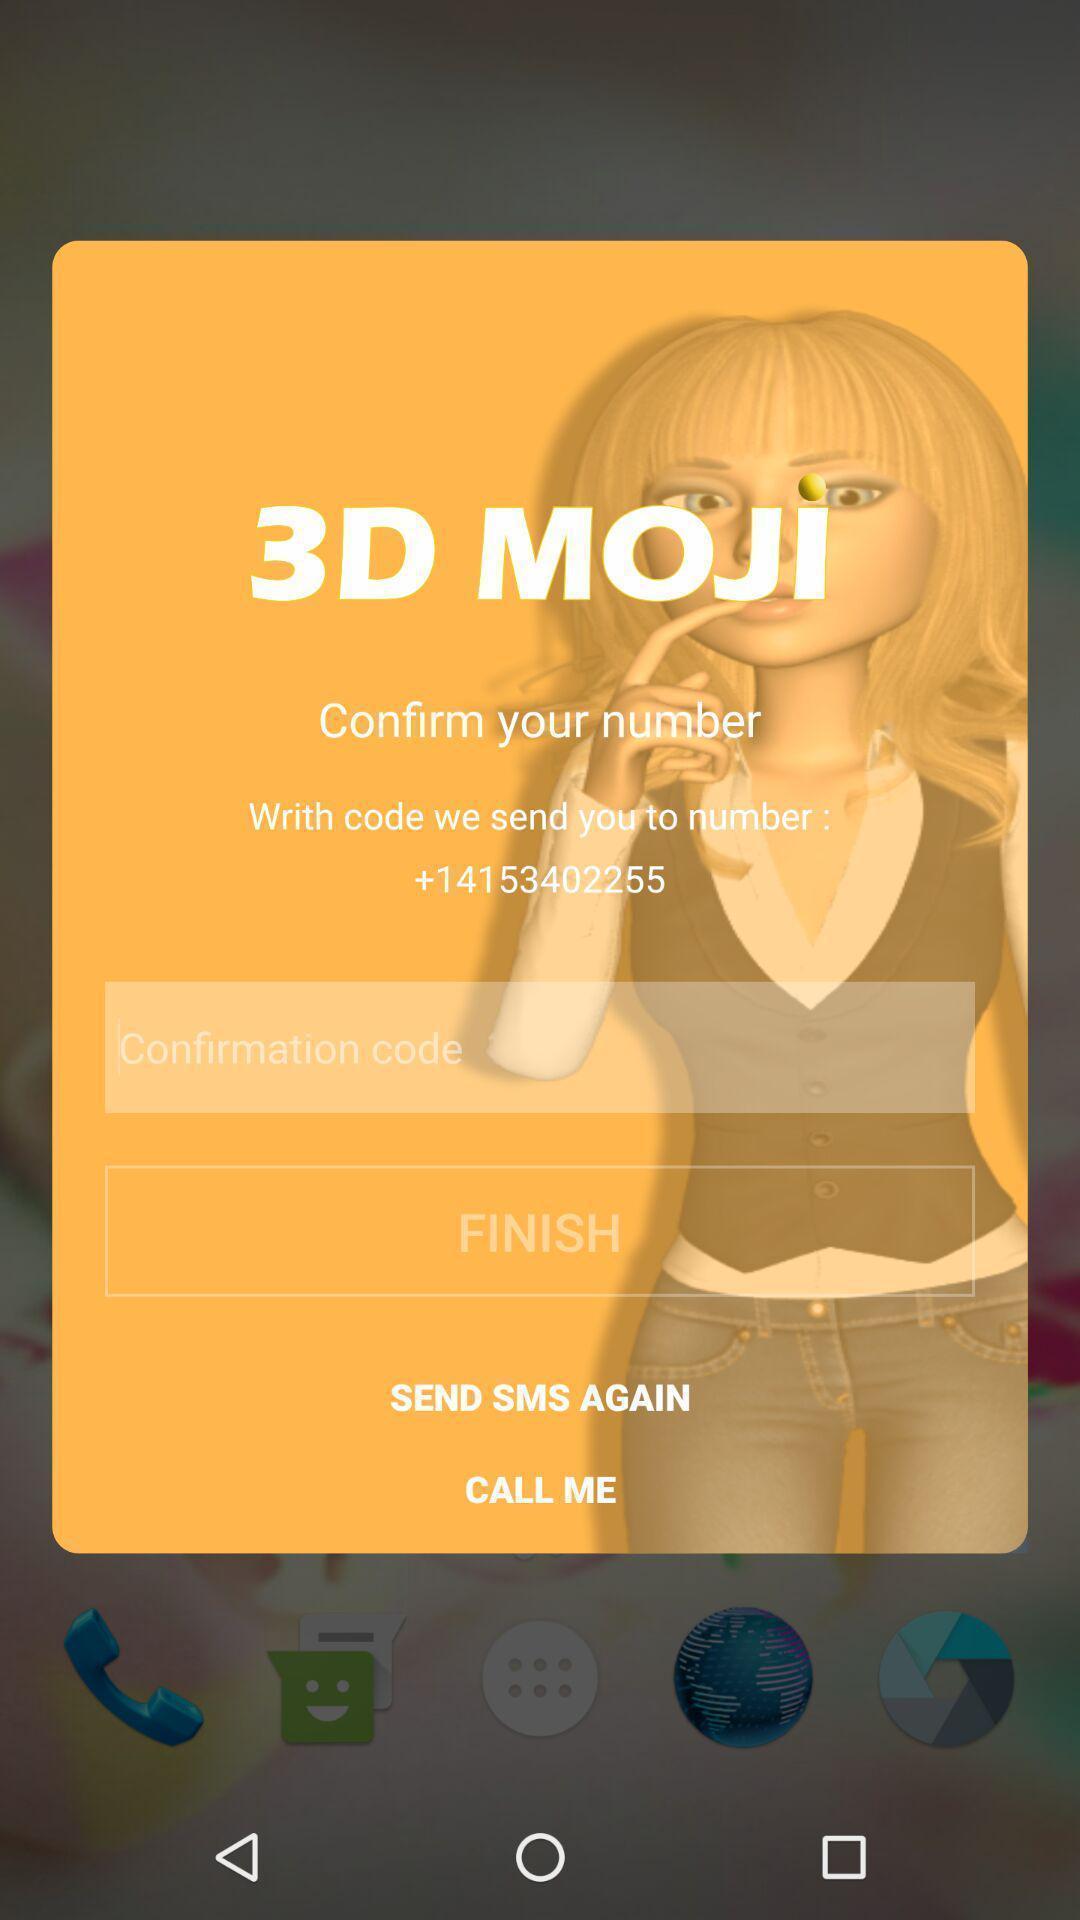Explain the elements present in this screenshot. Screen shows confirmation page. 